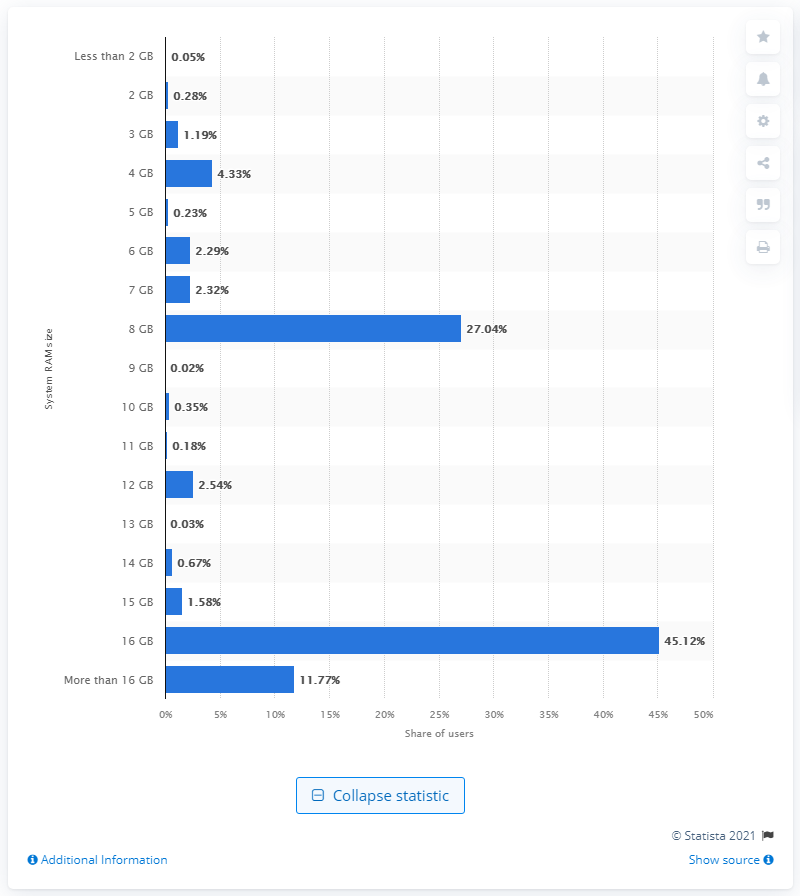Identify some key points in this picture. In March 2021, 45.12 percent of Steam users had 16 GB of RAM. According to data from March 2021, a significant portion of Steam users had 16 GB of RAM. Specifically, approximately 45.12% of users had this amount of RAM. 